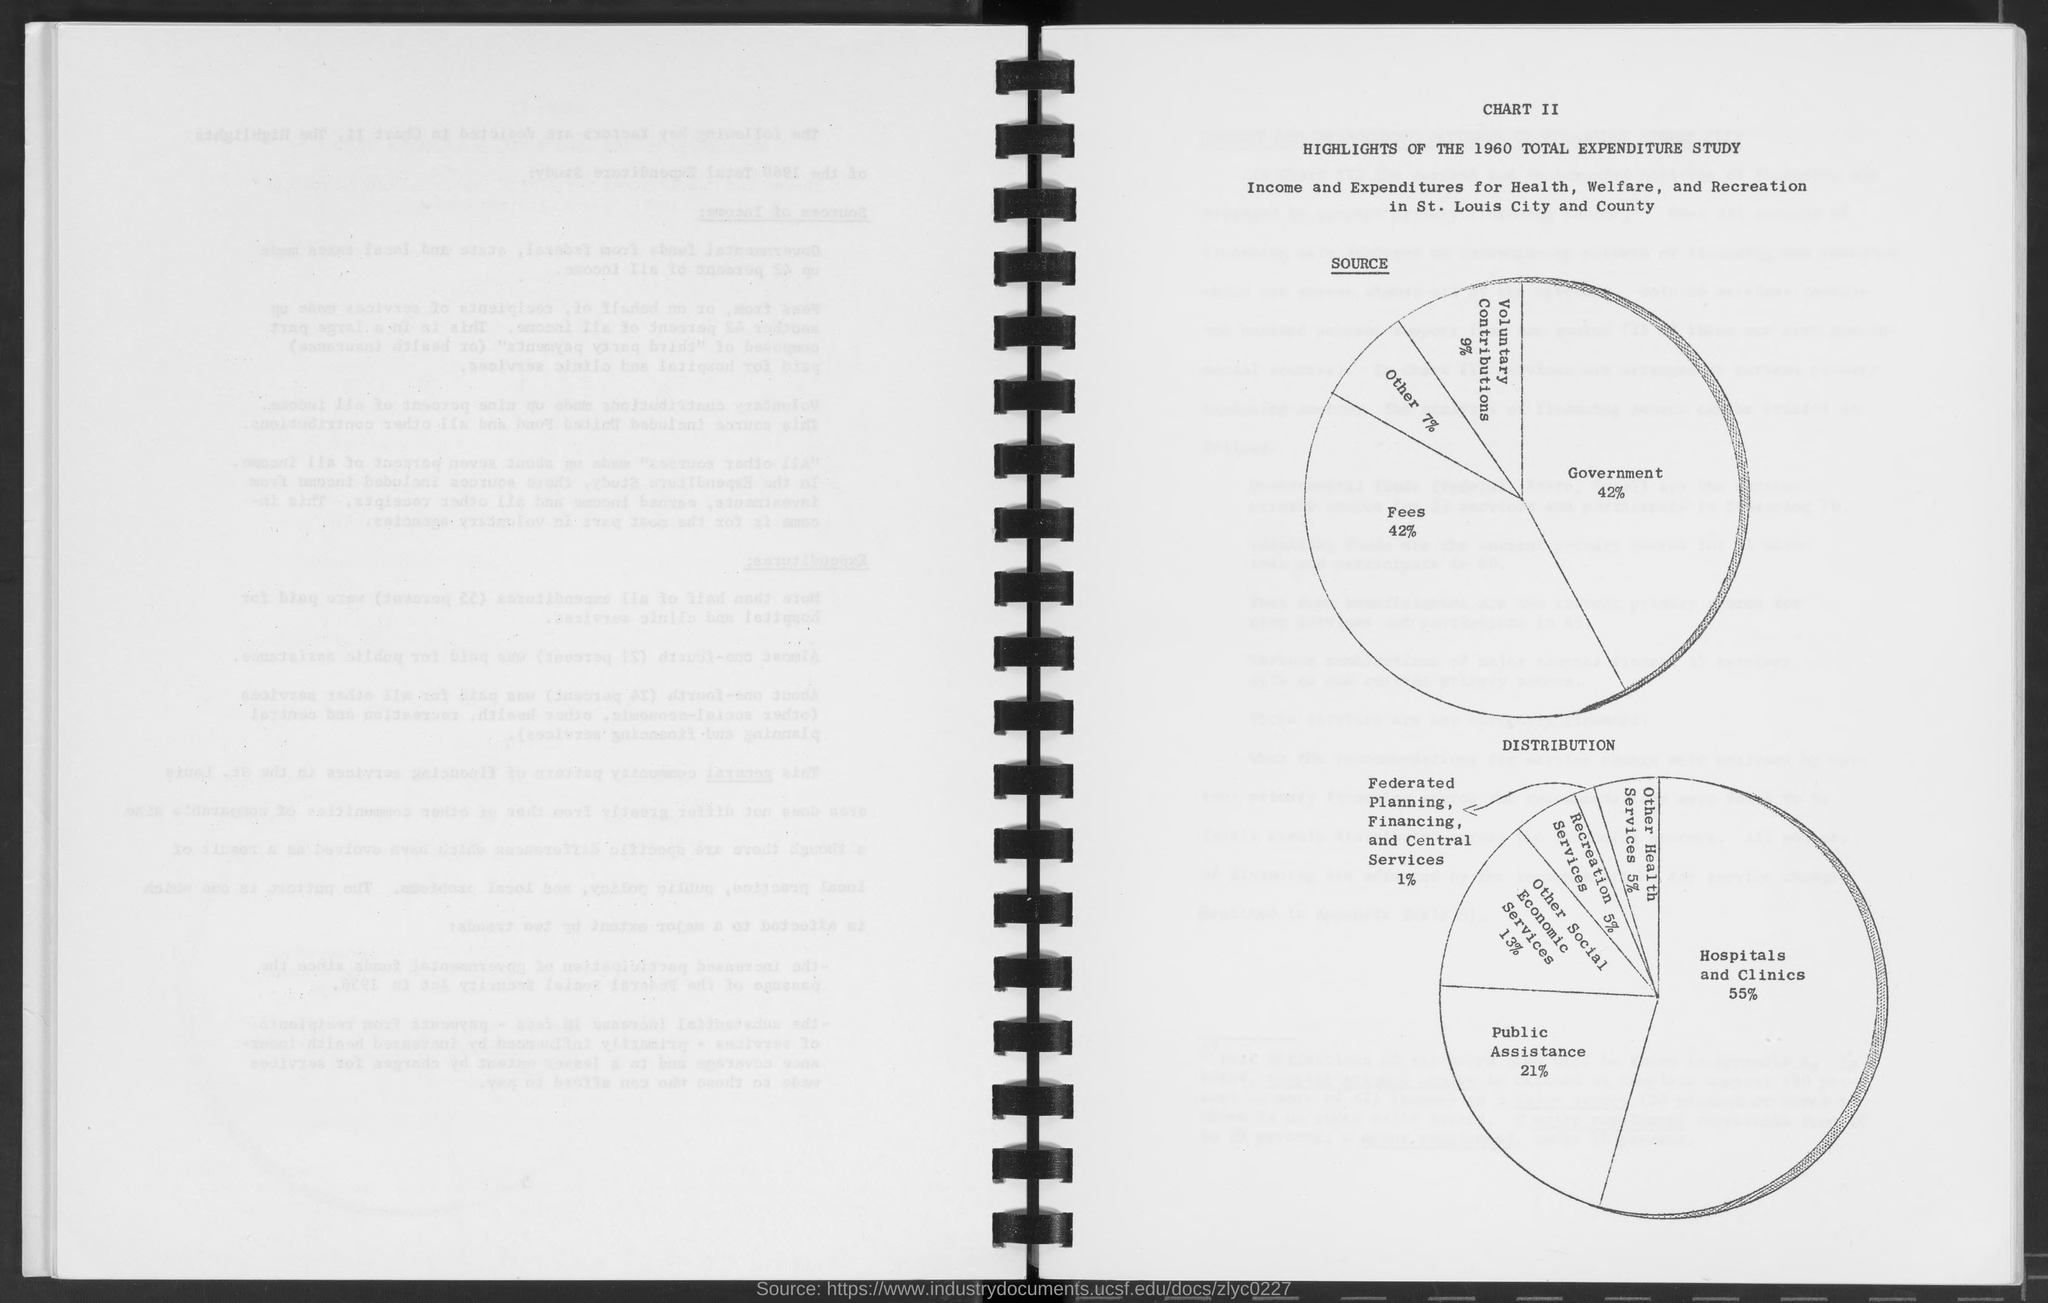Outline some significant characteristics in this image. According to the given page, the percentage of source for government is 42%. The recreation services distribution percentage mentioned on the given page is 5%. According to the given page, other health services make up 5% of the total distribution. The article states that out of the total distribution of social and economic services, 13% is dedicated to other social and economic services. According to the provided page, the percentage for public assistance in distribution is 21%. 